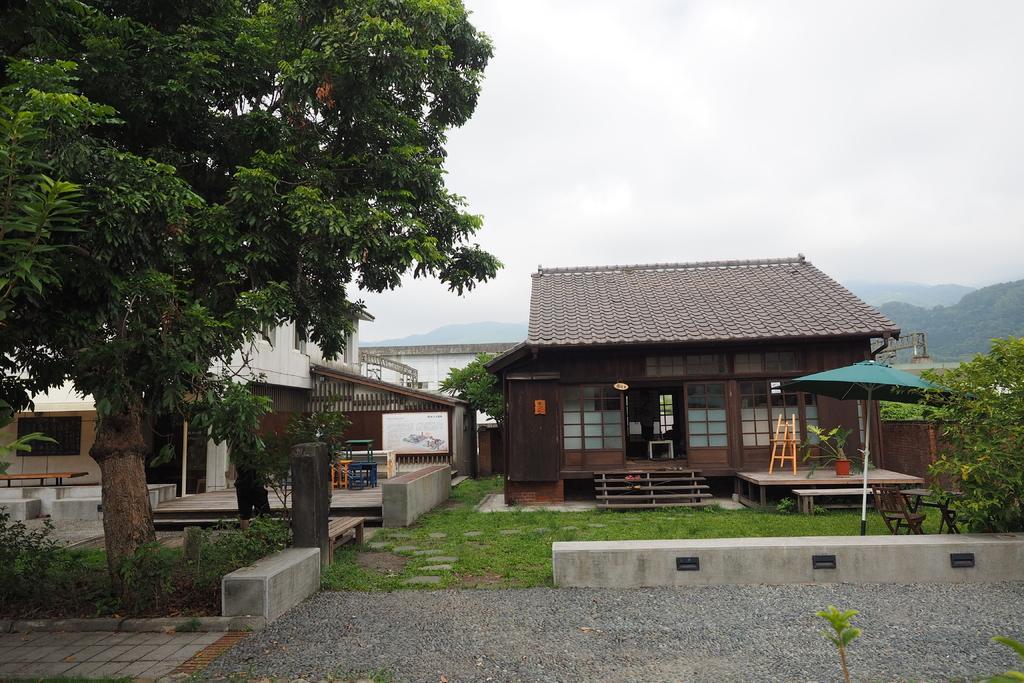Describe this image in one or two sentences. In this image I can see the houses. In-front of the houses I can see the tables, benches, and umbrella, flower pots, plants and trees. I can see also see the boards. In the background I can see few more trees, mountains, clouds and the sky. 